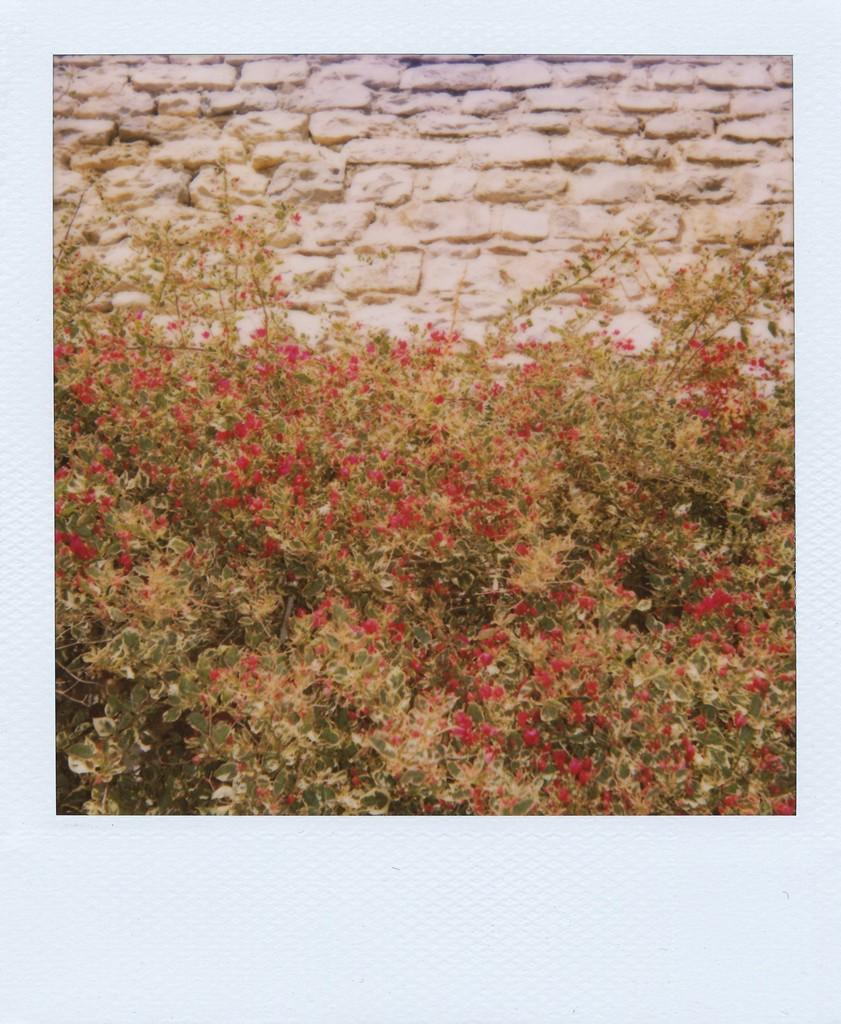What type of plants are visible in the image? There are plants with flowers in the image. What can be seen in the background of the image? There is a wall visible in the background of the image. Can you see a friend reading a quilt in the image? There is no friend or quilt present in the image; it features plants with flowers and a wall in the background. 